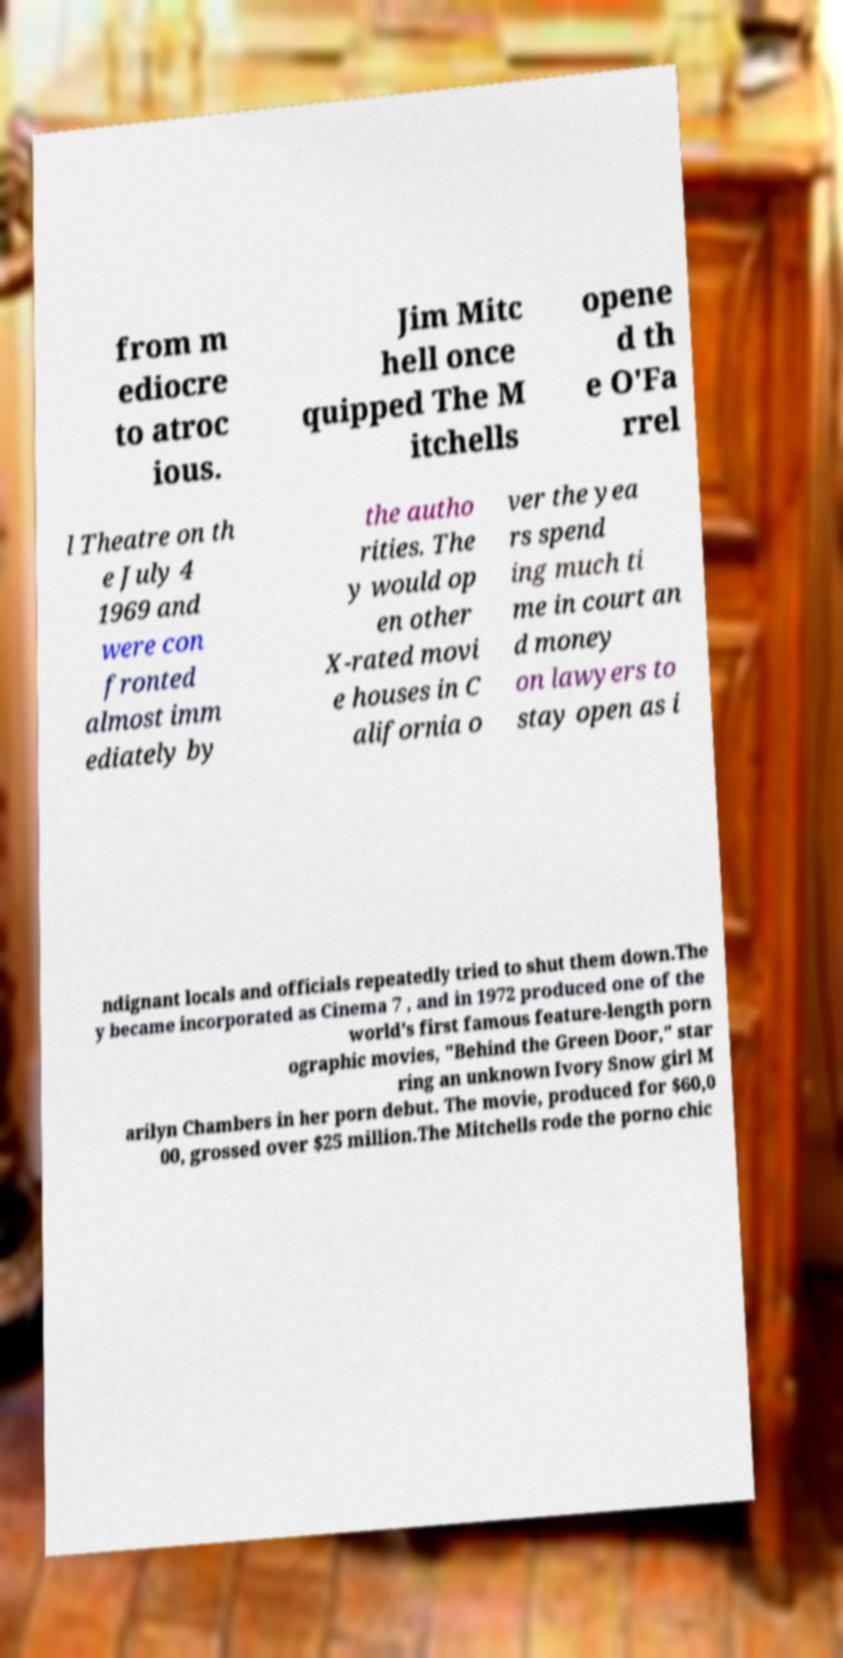Please identify and transcribe the text found in this image. from m ediocre to atroc ious. Jim Mitc hell once quipped The M itchells opene d th e O'Fa rrel l Theatre on th e July 4 1969 and were con fronted almost imm ediately by the autho rities. The y would op en other X-rated movi e houses in C alifornia o ver the yea rs spend ing much ti me in court an d money on lawyers to stay open as i ndignant locals and officials repeatedly tried to shut them down.The y became incorporated as Cinema 7 , and in 1972 produced one of the world's first famous feature-length porn ographic movies, "Behind the Green Door," star ring an unknown Ivory Snow girl M arilyn Chambers in her porn debut. The movie, produced for $60,0 00, grossed over $25 million.The Mitchells rode the porno chic 